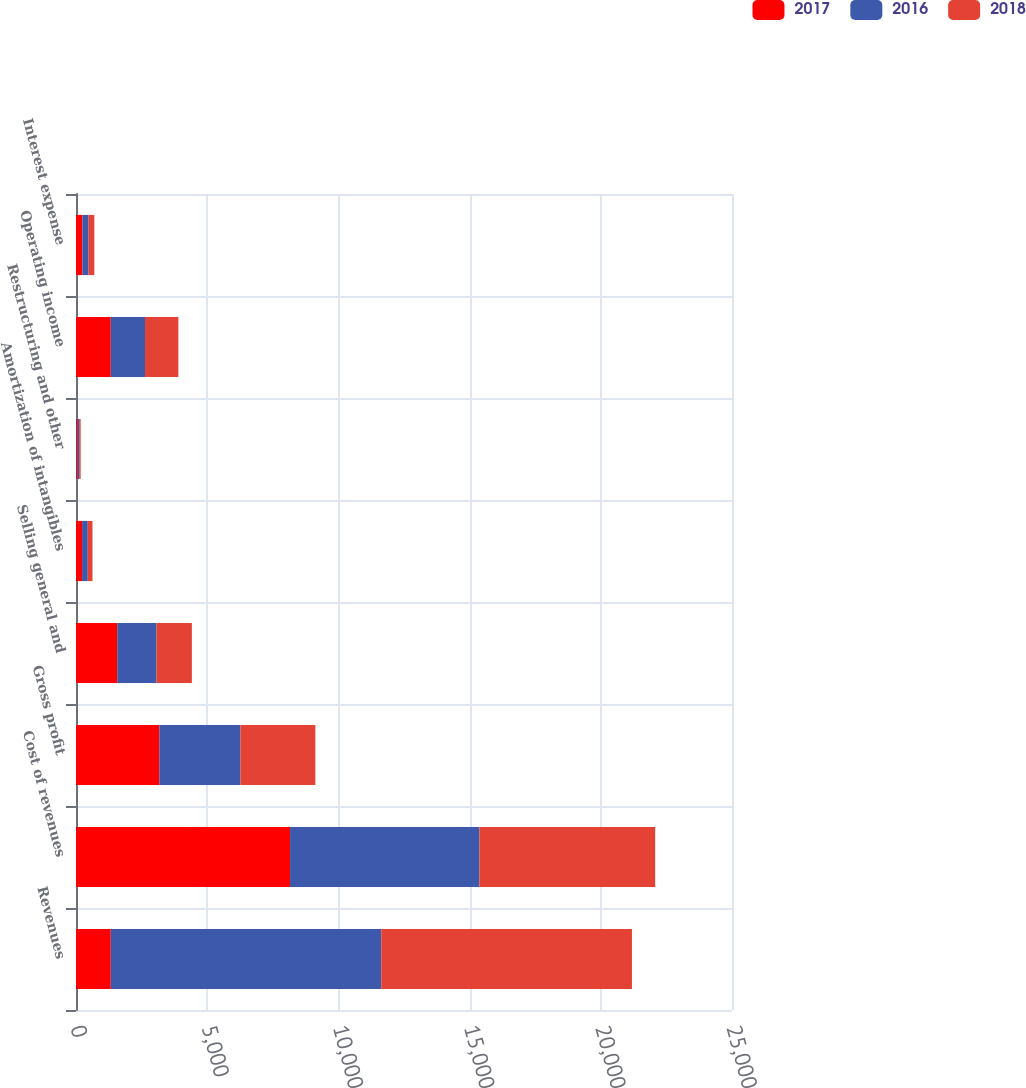Convert chart to OTSL. <chart><loc_0><loc_0><loc_500><loc_500><stacked_bar_chart><ecel><fcel>Revenues<fcel>Cost of revenues<fcel>Gross profit<fcel>Selling general and<fcel>Amortization of intangibles<fcel>Restructuring and other<fcel>Operating income<fcel>Interest expense<nl><fcel>2017<fcel>1325.7<fcel>8157<fcel>3176.4<fcel>1570.9<fcel>231.7<fcel>48.1<fcel>1325.7<fcel>244.2<nl><fcel>2016<fcel>10308<fcel>7216.2<fcel>3091.8<fcel>1499.2<fcel>216.5<fcel>70.9<fcel>1305.2<fcel>235.1<nl><fcel>2018<fcel>9552.9<fcel>6698.9<fcel>2854<fcel>1345.5<fcel>179.5<fcel>58.4<fcel>1270.6<fcel>219.1<nl></chart> 